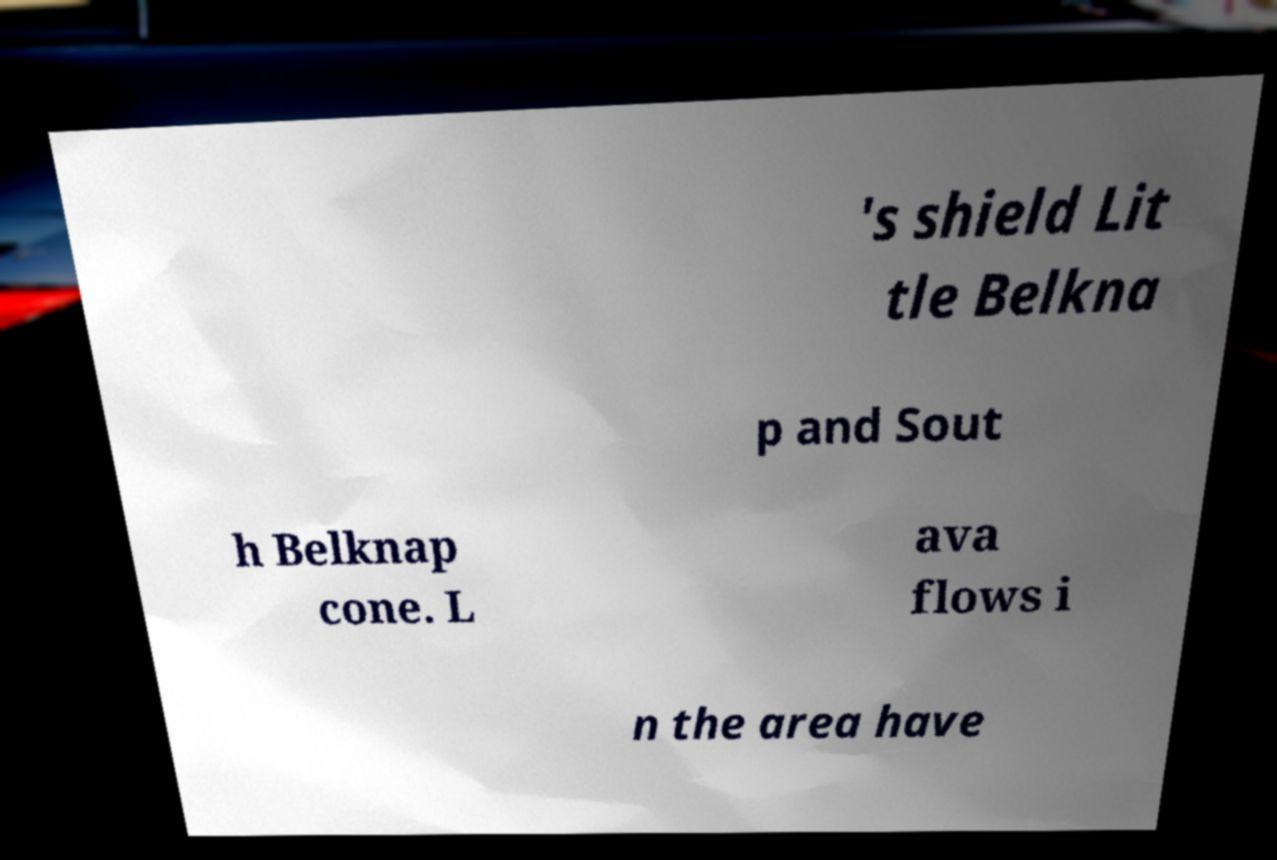Please read and relay the text visible in this image. What does it say? 's shield Lit tle Belkna p and Sout h Belknap cone. L ava flows i n the area have 